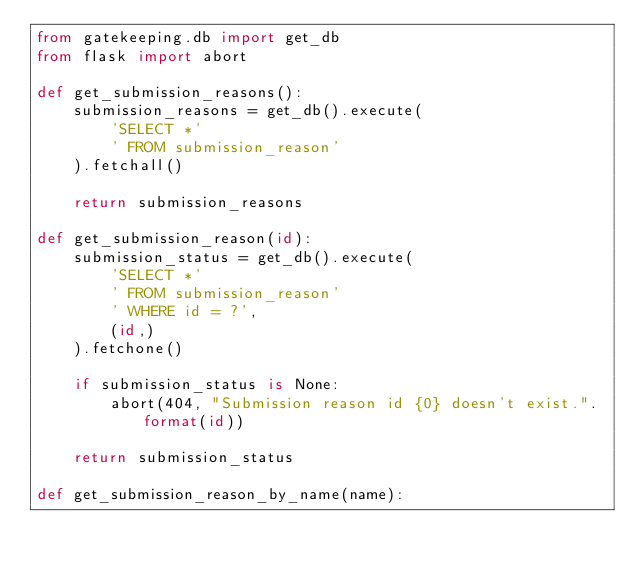<code> <loc_0><loc_0><loc_500><loc_500><_Python_>from gatekeeping.db import get_db
from flask import abort

def get_submission_reasons():
    submission_reasons = get_db().execute(
        'SELECT *'
        ' FROM submission_reason'
    ).fetchall()

    return submission_reasons

def get_submission_reason(id):
    submission_status = get_db().execute(
        'SELECT *'
        ' FROM submission_reason'
        ' WHERE id = ?',
        (id,)
    ).fetchone()

    if submission_status is None:
        abort(404, "Submission reason id {0} doesn't exist.".format(id))

    return submission_status

def get_submission_reason_by_name(name):</code> 